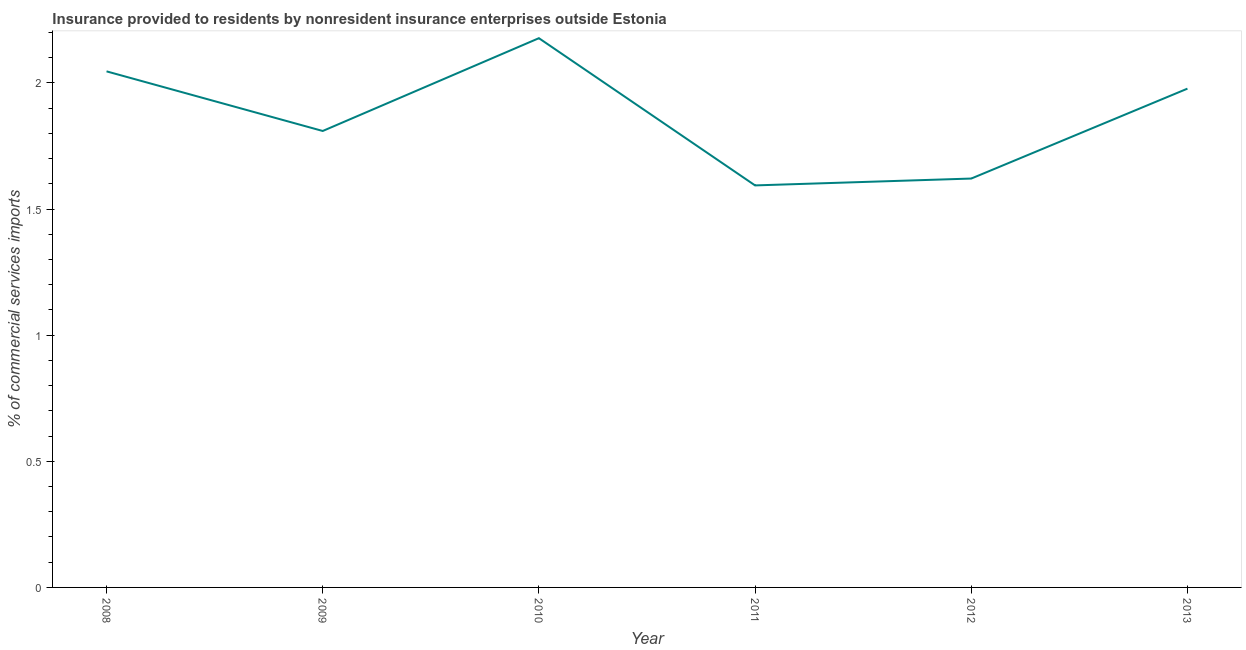What is the insurance provided by non-residents in 2009?
Your answer should be very brief. 1.81. Across all years, what is the maximum insurance provided by non-residents?
Provide a succinct answer. 2.18. Across all years, what is the minimum insurance provided by non-residents?
Your response must be concise. 1.59. In which year was the insurance provided by non-residents maximum?
Give a very brief answer. 2010. What is the sum of the insurance provided by non-residents?
Your response must be concise. 11.23. What is the difference between the insurance provided by non-residents in 2011 and 2012?
Give a very brief answer. -0.03. What is the average insurance provided by non-residents per year?
Your response must be concise. 1.87. What is the median insurance provided by non-residents?
Provide a short and direct response. 1.89. Do a majority of the years between 2013 and 2011 (inclusive) have insurance provided by non-residents greater than 1 %?
Provide a succinct answer. No. What is the ratio of the insurance provided by non-residents in 2010 to that in 2012?
Keep it short and to the point. 1.34. Is the insurance provided by non-residents in 2009 less than that in 2011?
Your answer should be very brief. No. What is the difference between the highest and the second highest insurance provided by non-residents?
Your answer should be compact. 0.13. What is the difference between the highest and the lowest insurance provided by non-residents?
Ensure brevity in your answer.  0.58. How many lines are there?
Offer a very short reply. 1. How many years are there in the graph?
Offer a terse response. 6. Does the graph contain any zero values?
Offer a terse response. No. Does the graph contain grids?
Your response must be concise. No. What is the title of the graph?
Offer a very short reply. Insurance provided to residents by nonresident insurance enterprises outside Estonia. What is the label or title of the X-axis?
Provide a succinct answer. Year. What is the label or title of the Y-axis?
Provide a succinct answer. % of commercial services imports. What is the % of commercial services imports in 2008?
Offer a terse response. 2.05. What is the % of commercial services imports in 2009?
Offer a very short reply. 1.81. What is the % of commercial services imports in 2010?
Your response must be concise. 2.18. What is the % of commercial services imports in 2011?
Keep it short and to the point. 1.59. What is the % of commercial services imports in 2012?
Your answer should be compact. 1.62. What is the % of commercial services imports in 2013?
Offer a terse response. 1.98. What is the difference between the % of commercial services imports in 2008 and 2009?
Offer a very short reply. 0.24. What is the difference between the % of commercial services imports in 2008 and 2010?
Your answer should be very brief. -0.13. What is the difference between the % of commercial services imports in 2008 and 2011?
Your answer should be very brief. 0.45. What is the difference between the % of commercial services imports in 2008 and 2012?
Offer a very short reply. 0.42. What is the difference between the % of commercial services imports in 2008 and 2013?
Provide a short and direct response. 0.07. What is the difference between the % of commercial services imports in 2009 and 2010?
Offer a very short reply. -0.37. What is the difference between the % of commercial services imports in 2009 and 2011?
Offer a very short reply. 0.22. What is the difference between the % of commercial services imports in 2009 and 2012?
Your answer should be compact. 0.19. What is the difference between the % of commercial services imports in 2009 and 2013?
Keep it short and to the point. -0.17. What is the difference between the % of commercial services imports in 2010 and 2011?
Give a very brief answer. 0.58. What is the difference between the % of commercial services imports in 2010 and 2012?
Your answer should be compact. 0.56. What is the difference between the % of commercial services imports in 2010 and 2013?
Make the answer very short. 0.2. What is the difference between the % of commercial services imports in 2011 and 2012?
Offer a terse response. -0.03. What is the difference between the % of commercial services imports in 2011 and 2013?
Your response must be concise. -0.38. What is the difference between the % of commercial services imports in 2012 and 2013?
Make the answer very short. -0.36. What is the ratio of the % of commercial services imports in 2008 to that in 2009?
Your answer should be compact. 1.13. What is the ratio of the % of commercial services imports in 2008 to that in 2010?
Offer a terse response. 0.94. What is the ratio of the % of commercial services imports in 2008 to that in 2011?
Offer a very short reply. 1.28. What is the ratio of the % of commercial services imports in 2008 to that in 2012?
Give a very brief answer. 1.26. What is the ratio of the % of commercial services imports in 2008 to that in 2013?
Offer a terse response. 1.03. What is the ratio of the % of commercial services imports in 2009 to that in 2010?
Keep it short and to the point. 0.83. What is the ratio of the % of commercial services imports in 2009 to that in 2011?
Ensure brevity in your answer.  1.14. What is the ratio of the % of commercial services imports in 2009 to that in 2012?
Provide a succinct answer. 1.12. What is the ratio of the % of commercial services imports in 2009 to that in 2013?
Provide a short and direct response. 0.92. What is the ratio of the % of commercial services imports in 2010 to that in 2011?
Offer a terse response. 1.37. What is the ratio of the % of commercial services imports in 2010 to that in 2012?
Offer a terse response. 1.34. What is the ratio of the % of commercial services imports in 2010 to that in 2013?
Provide a succinct answer. 1.1. What is the ratio of the % of commercial services imports in 2011 to that in 2013?
Your answer should be compact. 0.81. What is the ratio of the % of commercial services imports in 2012 to that in 2013?
Offer a very short reply. 0.82. 